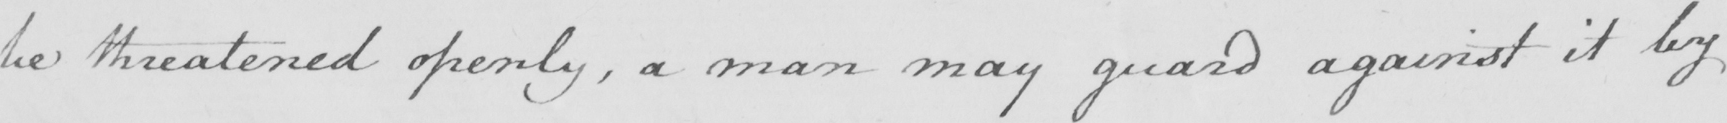What is written in this line of handwriting? be threatened openly , a man may guard against it by 